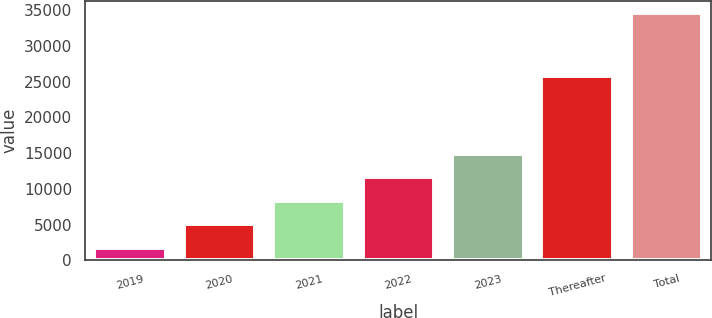Convert chart to OTSL. <chart><loc_0><loc_0><loc_500><loc_500><bar_chart><fcel>2019<fcel>2020<fcel>2021<fcel>2022<fcel>2023<fcel>Thereafter<fcel>Total<nl><fcel>1775<fcel>5058.8<fcel>8342.6<fcel>11626.4<fcel>14910.2<fcel>25738<fcel>34613<nl></chart> 